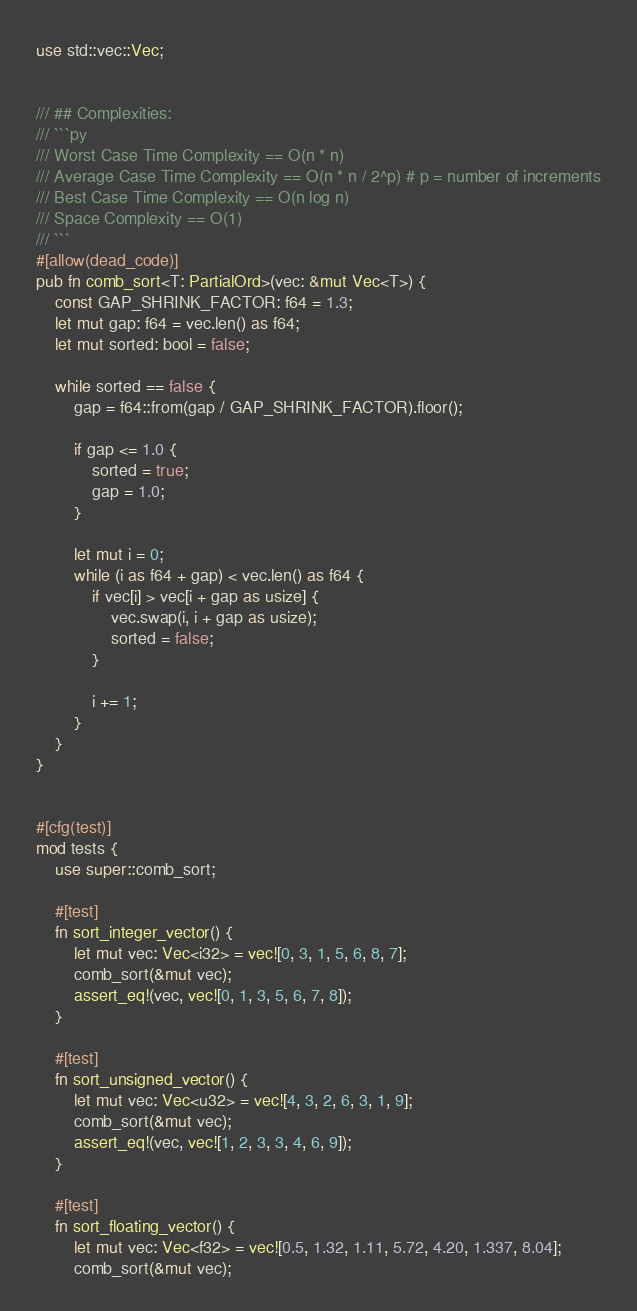Convert code to text. <code><loc_0><loc_0><loc_500><loc_500><_Rust_>use std::vec::Vec;


/// ## Complexities:
/// ```py
/// Worst Case Time Complexity == O(n * n)
/// Average Case Time Complexity == O(n * n / 2^p) # p = number of increments
/// Best Case Time Complexity == O(n log n)
/// Space Complexity == O(1)
/// ```
#[allow(dead_code)]
pub fn comb_sort<T: PartialOrd>(vec: &mut Vec<T>) {
    const GAP_SHRINK_FACTOR: f64 = 1.3;
    let mut gap: f64 = vec.len() as f64;
    let mut sorted: bool = false;

    while sorted == false {
        gap = f64::from(gap / GAP_SHRINK_FACTOR).floor();

        if gap <= 1.0 {
            sorted = true;
            gap = 1.0;
        }

        let mut i = 0;
        while (i as f64 + gap) < vec.len() as f64 {
            if vec[i] > vec[i + gap as usize] {
                vec.swap(i, i + gap as usize);
                sorted = false;
            }

            i += 1;
        }
    }
}


#[cfg(test)]
mod tests {
    use super::comb_sort;

    #[test]
    fn sort_integer_vector() {
        let mut vec: Vec<i32> = vec![0, 3, 1, 5, 6, 8, 7];
        comb_sort(&mut vec);
        assert_eq!(vec, vec![0, 1, 3, 5, 6, 7, 8]);
    }

    #[test]
    fn sort_unsigned_vector() {
        let mut vec: Vec<u32> = vec![4, 3, 2, 6, 3, 1, 9];
        comb_sort(&mut vec);
        assert_eq!(vec, vec![1, 2, 3, 3, 4, 6, 9]);
    }

    #[test]
    fn sort_floating_vector() {
        let mut vec: Vec<f32> = vec![0.5, 1.32, 1.11, 5.72, 4.20, 1.337, 8.04];
        comb_sort(&mut vec);</code> 